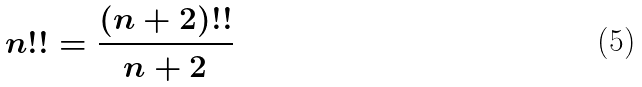<formula> <loc_0><loc_0><loc_500><loc_500>n ! ! = \frac { ( n + 2 ) ! ! } { n + 2 }</formula> 